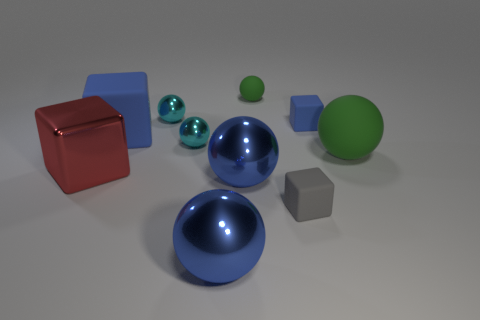Subtract all green cylinders. How many green spheres are left? 2 Subtract all big blue matte cubes. How many cubes are left? 3 Subtract all blue spheres. How many spheres are left? 4 Subtract 1 spheres. How many spheres are left? 5 Subtract all blue spheres. Subtract all yellow cubes. How many spheres are left? 4 Subtract all cubes. How many objects are left? 6 Add 9 small blue rubber blocks. How many small blue rubber blocks are left? 10 Add 4 tiny green spheres. How many tiny green spheres exist? 5 Subtract 0 cyan blocks. How many objects are left? 10 Subtract all small green things. Subtract all blue blocks. How many objects are left? 7 